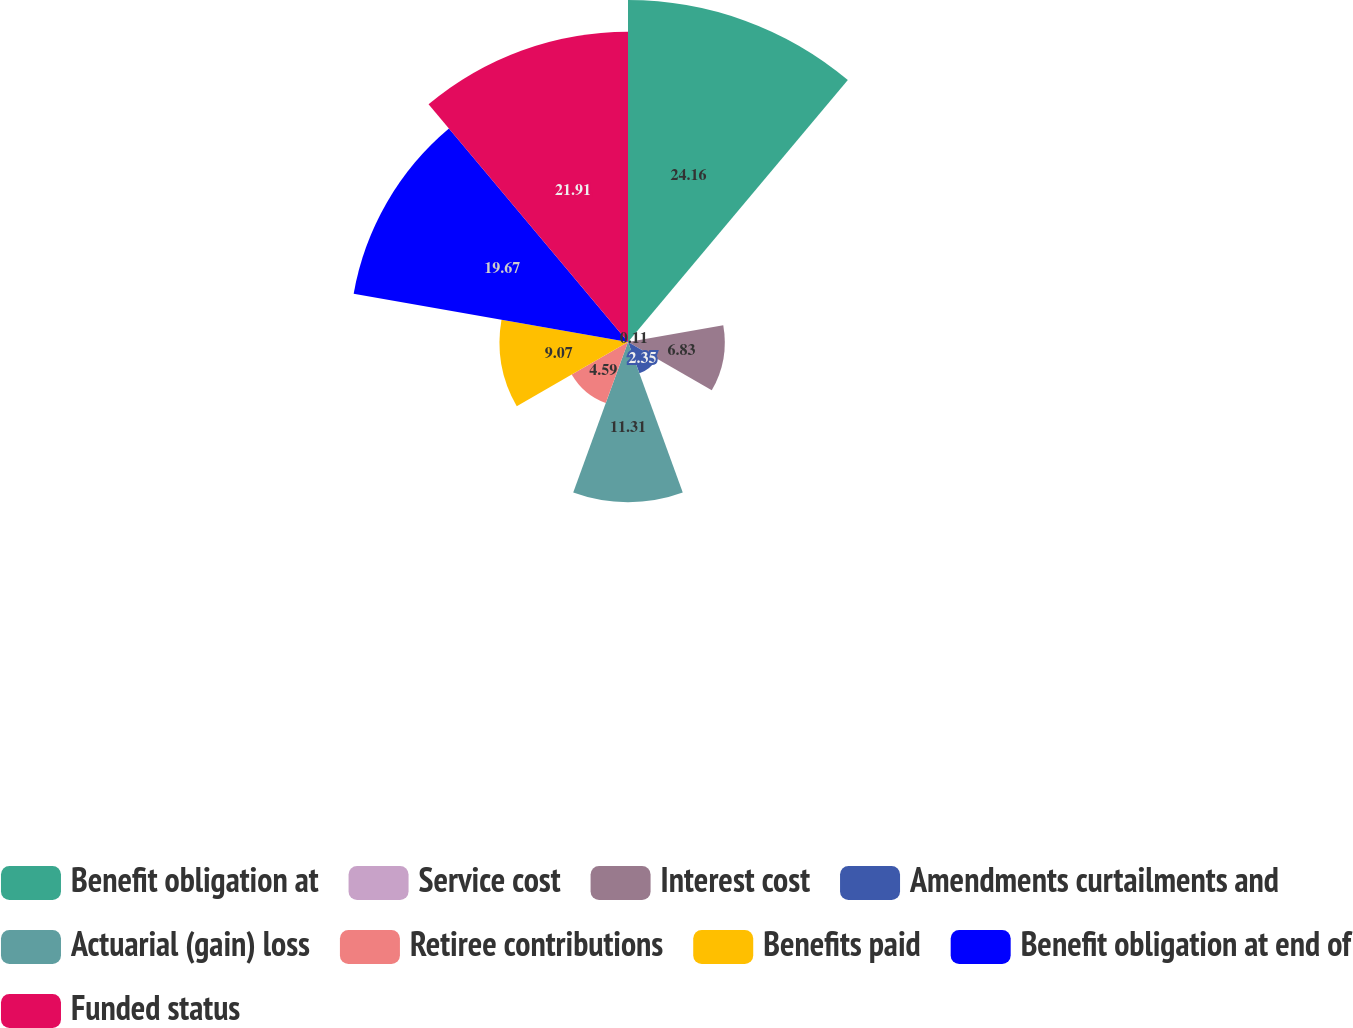Convert chart. <chart><loc_0><loc_0><loc_500><loc_500><pie_chart><fcel>Benefit obligation at<fcel>Service cost<fcel>Interest cost<fcel>Amendments curtailments and<fcel>Actuarial (gain) loss<fcel>Retiree contributions<fcel>Benefits paid<fcel>Benefit obligation at end of<fcel>Funded status<nl><fcel>24.15%<fcel>0.11%<fcel>6.83%<fcel>2.35%<fcel>11.31%<fcel>4.59%<fcel>9.07%<fcel>19.67%<fcel>21.91%<nl></chart> 